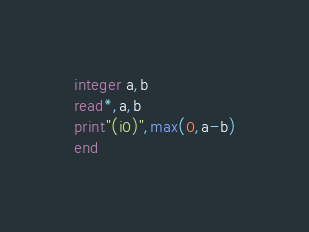<code> <loc_0><loc_0><loc_500><loc_500><_FORTRAN_>integer a,b
read*,a,b
print"(i0)",max(0,a-b)
end</code> 